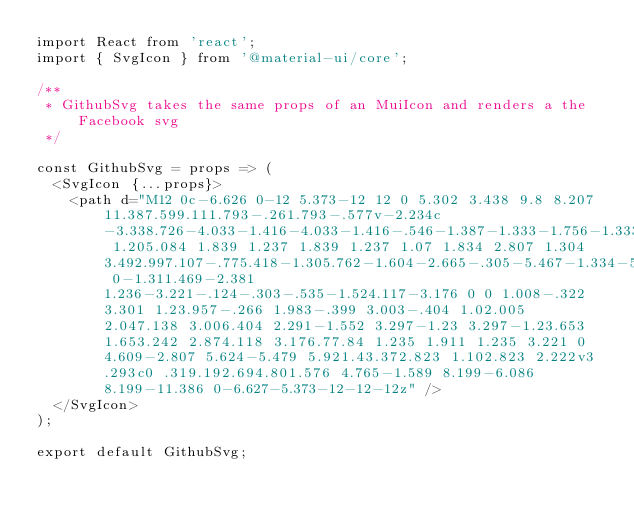Convert code to text. <code><loc_0><loc_0><loc_500><loc_500><_JavaScript_>import React from 'react';
import { SvgIcon } from '@material-ui/core';

/**
 * GithubSvg takes the same props of an MuiIcon and renders a the Facebook svg
 */

const GithubSvg = props => (
  <SvgIcon {...props}>
    <path d="M12 0c-6.626 0-12 5.373-12 12 0 5.302 3.438 9.8 8.207 11.387.599.111.793-.261.793-.577v-2.234c-3.338.726-4.033-1.416-4.033-1.416-.546-1.387-1.333-1.756-1.333-1.756-1.089-.745.083-.729.083-.729 1.205.084 1.839 1.237 1.839 1.237 1.07 1.834 2.807 1.304 3.492.997.107-.775.418-1.305.762-1.604-2.665-.305-5.467-1.334-5.467-5.931 0-1.311.469-2.381 1.236-3.221-.124-.303-.535-1.524.117-3.176 0 0 1.008-.322 3.301 1.23.957-.266 1.983-.399 3.003-.404 1.02.005 2.047.138 3.006.404 2.291-1.552 3.297-1.23 3.297-1.23.653 1.653.242 2.874.118 3.176.77.84 1.235 1.911 1.235 3.221 0 4.609-2.807 5.624-5.479 5.921.43.372.823 1.102.823 2.222v3.293c0 .319.192.694.801.576 4.765-1.589 8.199-6.086 8.199-11.386 0-6.627-5.373-12-12-12z" />
  </SvgIcon>
);

export default GithubSvg;
</code> 